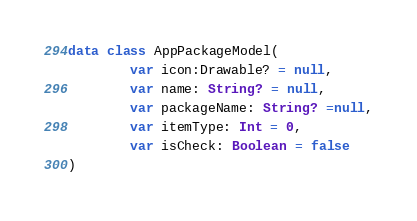<code> <loc_0><loc_0><loc_500><loc_500><_Kotlin_>
data class AppPackageModel(
        var icon:Drawable? = null,
        var name: String? = null,
        var packageName: String? =null,
        var itemType: Int = 0,
        var isCheck: Boolean = false
)


</code> 